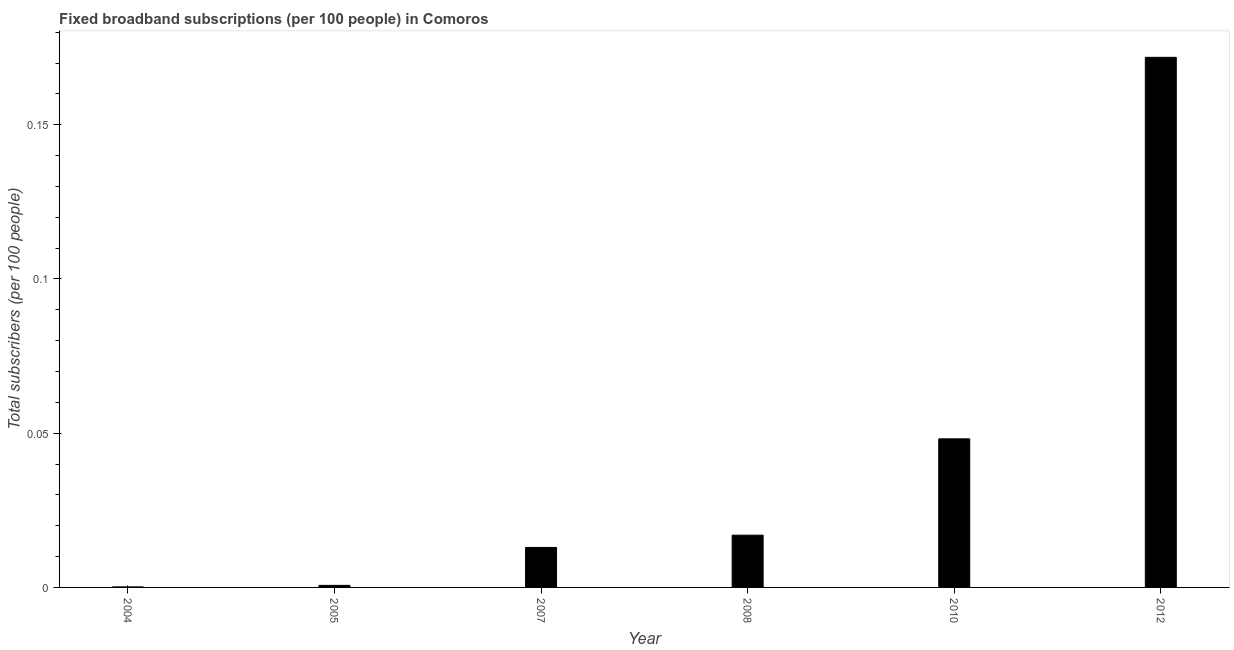Does the graph contain grids?
Ensure brevity in your answer.  No. What is the title of the graph?
Provide a short and direct response. Fixed broadband subscriptions (per 100 people) in Comoros. What is the label or title of the Y-axis?
Your answer should be compact. Total subscribers (per 100 people). What is the total number of fixed broadband subscriptions in 2005?
Make the answer very short. 0. Across all years, what is the maximum total number of fixed broadband subscriptions?
Ensure brevity in your answer.  0.17. Across all years, what is the minimum total number of fixed broadband subscriptions?
Provide a short and direct response. 0. In which year was the total number of fixed broadband subscriptions maximum?
Keep it short and to the point. 2012. What is the sum of the total number of fixed broadband subscriptions?
Give a very brief answer. 0.25. What is the difference between the total number of fixed broadband subscriptions in 2005 and 2010?
Offer a terse response. -0.05. What is the average total number of fixed broadband subscriptions per year?
Your answer should be very brief. 0.04. What is the median total number of fixed broadband subscriptions?
Offer a very short reply. 0.01. What is the ratio of the total number of fixed broadband subscriptions in 2005 to that in 2012?
Give a very brief answer. 0. Is the difference between the total number of fixed broadband subscriptions in 2007 and 2012 greater than the difference between any two years?
Keep it short and to the point. No. What is the difference between the highest and the second highest total number of fixed broadband subscriptions?
Your answer should be very brief. 0.12. What is the difference between the highest and the lowest total number of fixed broadband subscriptions?
Your response must be concise. 0.17. In how many years, is the total number of fixed broadband subscriptions greater than the average total number of fixed broadband subscriptions taken over all years?
Keep it short and to the point. 2. How many bars are there?
Offer a very short reply. 6. Are all the bars in the graph horizontal?
Your answer should be very brief. No. How many years are there in the graph?
Your response must be concise. 6. What is the difference between two consecutive major ticks on the Y-axis?
Give a very brief answer. 0.05. What is the Total subscribers (per 100 people) in 2004?
Offer a terse response. 0. What is the Total subscribers (per 100 people) of 2005?
Offer a terse response. 0. What is the Total subscribers (per 100 people) of 2007?
Offer a very short reply. 0.01. What is the Total subscribers (per 100 people) in 2008?
Ensure brevity in your answer.  0.02. What is the Total subscribers (per 100 people) in 2010?
Provide a succinct answer. 0.05. What is the Total subscribers (per 100 people) in 2012?
Make the answer very short. 0.17. What is the difference between the Total subscribers (per 100 people) in 2004 and 2005?
Provide a short and direct response. -0. What is the difference between the Total subscribers (per 100 people) in 2004 and 2007?
Give a very brief answer. -0.01. What is the difference between the Total subscribers (per 100 people) in 2004 and 2008?
Provide a succinct answer. -0.02. What is the difference between the Total subscribers (per 100 people) in 2004 and 2010?
Provide a succinct answer. -0.05. What is the difference between the Total subscribers (per 100 people) in 2004 and 2012?
Keep it short and to the point. -0.17. What is the difference between the Total subscribers (per 100 people) in 2005 and 2007?
Give a very brief answer. -0.01. What is the difference between the Total subscribers (per 100 people) in 2005 and 2008?
Give a very brief answer. -0.02. What is the difference between the Total subscribers (per 100 people) in 2005 and 2010?
Offer a terse response. -0.05. What is the difference between the Total subscribers (per 100 people) in 2005 and 2012?
Keep it short and to the point. -0.17. What is the difference between the Total subscribers (per 100 people) in 2007 and 2008?
Keep it short and to the point. -0. What is the difference between the Total subscribers (per 100 people) in 2007 and 2010?
Your answer should be compact. -0.04. What is the difference between the Total subscribers (per 100 people) in 2007 and 2012?
Offer a very short reply. -0.16. What is the difference between the Total subscribers (per 100 people) in 2008 and 2010?
Ensure brevity in your answer.  -0.03. What is the difference between the Total subscribers (per 100 people) in 2008 and 2012?
Provide a short and direct response. -0.15. What is the difference between the Total subscribers (per 100 people) in 2010 and 2012?
Provide a short and direct response. -0.12. What is the ratio of the Total subscribers (per 100 people) in 2004 to that in 2005?
Your response must be concise. 0.26. What is the ratio of the Total subscribers (per 100 people) in 2004 to that in 2007?
Ensure brevity in your answer.  0.01. What is the ratio of the Total subscribers (per 100 people) in 2004 to that in 2008?
Ensure brevity in your answer.  0.01. What is the ratio of the Total subscribers (per 100 people) in 2004 to that in 2010?
Provide a short and direct response. 0. What is the ratio of the Total subscribers (per 100 people) in 2005 to that in 2007?
Provide a short and direct response. 0.05. What is the ratio of the Total subscribers (per 100 people) in 2005 to that in 2008?
Offer a very short reply. 0.04. What is the ratio of the Total subscribers (per 100 people) in 2005 to that in 2010?
Provide a short and direct response. 0.01. What is the ratio of the Total subscribers (per 100 people) in 2005 to that in 2012?
Keep it short and to the point. 0. What is the ratio of the Total subscribers (per 100 people) in 2007 to that in 2008?
Make the answer very short. 0.77. What is the ratio of the Total subscribers (per 100 people) in 2007 to that in 2010?
Give a very brief answer. 0.27. What is the ratio of the Total subscribers (per 100 people) in 2007 to that in 2012?
Your answer should be compact. 0.07. What is the ratio of the Total subscribers (per 100 people) in 2008 to that in 2010?
Your answer should be compact. 0.35. What is the ratio of the Total subscribers (per 100 people) in 2008 to that in 2012?
Make the answer very short. 0.1. What is the ratio of the Total subscribers (per 100 people) in 2010 to that in 2012?
Provide a succinct answer. 0.28. 